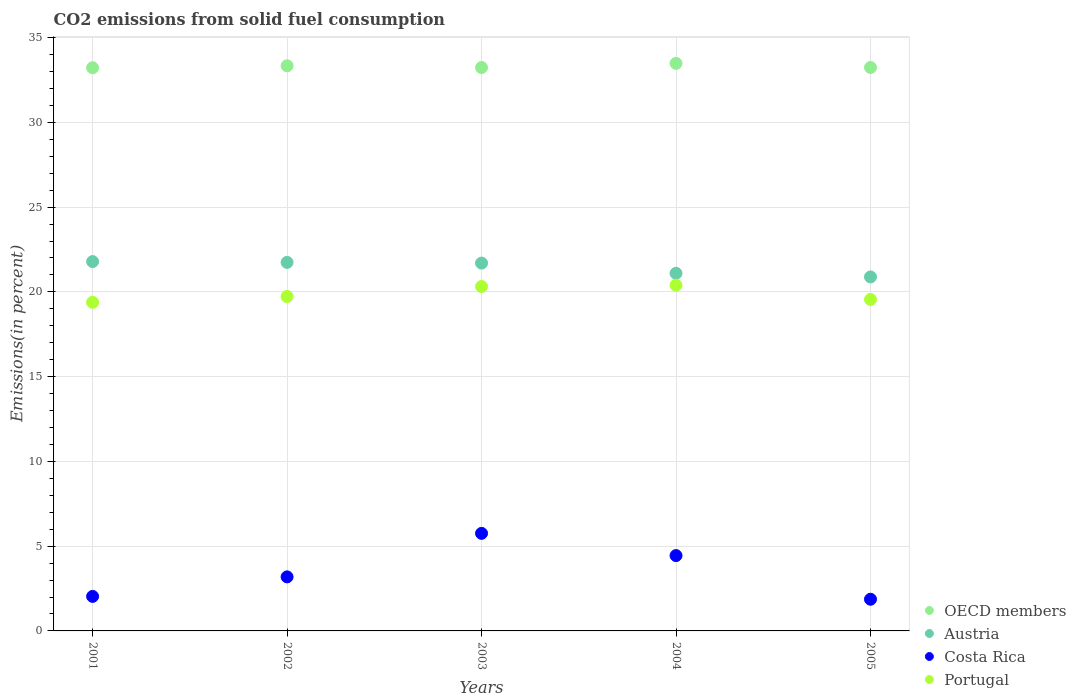How many different coloured dotlines are there?
Keep it short and to the point. 4. What is the total CO2 emitted in OECD members in 2002?
Keep it short and to the point. 33.34. Across all years, what is the maximum total CO2 emitted in Costa Rica?
Offer a terse response. 5.76. Across all years, what is the minimum total CO2 emitted in Portugal?
Your answer should be very brief. 19.38. In which year was the total CO2 emitted in Costa Rica maximum?
Ensure brevity in your answer.  2003. What is the total total CO2 emitted in Costa Rica in the graph?
Give a very brief answer. 17.29. What is the difference between the total CO2 emitted in Portugal in 2002 and that in 2004?
Offer a very short reply. -0.67. What is the difference between the total CO2 emitted in Portugal in 2002 and the total CO2 emitted in OECD members in 2001?
Your answer should be compact. -13.49. What is the average total CO2 emitted in Austria per year?
Your response must be concise. 21.44. In the year 2005, what is the difference between the total CO2 emitted in Portugal and total CO2 emitted in Austria?
Provide a succinct answer. -1.33. What is the ratio of the total CO2 emitted in OECD members in 2002 to that in 2005?
Provide a succinct answer. 1. Is the total CO2 emitted in OECD members in 2001 less than that in 2004?
Provide a succinct answer. Yes. Is the difference between the total CO2 emitted in Portugal in 2002 and 2004 greater than the difference between the total CO2 emitted in Austria in 2002 and 2004?
Keep it short and to the point. No. What is the difference between the highest and the second highest total CO2 emitted in Austria?
Your answer should be compact. 0.05. What is the difference between the highest and the lowest total CO2 emitted in Austria?
Offer a terse response. 0.91. In how many years, is the total CO2 emitted in Costa Rica greater than the average total CO2 emitted in Costa Rica taken over all years?
Give a very brief answer. 2. Is it the case that in every year, the sum of the total CO2 emitted in Austria and total CO2 emitted in Portugal  is greater than the total CO2 emitted in Costa Rica?
Keep it short and to the point. Yes. Is the total CO2 emitted in OECD members strictly greater than the total CO2 emitted in Austria over the years?
Ensure brevity in your answer.  Yes. How many years are there in the graph?
Make the answer very short. 5. Are the values on the major ticks of Y-axis written in scientific E-notation?
Offer a terse response. No. Does the graph contain any zero values?
Make the answer very short. No. Where does the legend appear in the graph?
Keep it short and to the point. Bottom right. How many legend labels are there?
Keep it short and to the point. 4. What is the title of the graph?
Provide a short and direct response. CO2 emissions from solid fuel consumption. What is the label or title of the X-axis?
Keep it short and to the point. Years. What is the label or title of the Y-axis?
Your answer should be compact. Emissions(in percent). What is the Emissions(in percent) in OECD members in 2001?
Keep it short and to the point. 33.22. What is the Emissions(in percent) in Austria in 2001?
Provide a succinct answer. 21.79. What is the Emissions(in percent) of Costa Rica in 2001?
Offer a very short reply. 2.04. What is the Emissions(in percent) of Portugal in 2001?
Your answer should be compact. 19.38. What is the Emissions(in percent) of OECD members in 2002?
Your answer should be compact. 33.34. What is the Emissions(in percent) of Austria in 2002?
Offer a very short reply. 21.74. What is the Emissions(in percent) in Costa Rica in 2002?
Give a very brief answer. 3.19. What is the Emissions(in percent) of Portugal in 2002?
Offer a terse response. 19.73. What is the Emissions(in percent) of OECD members in 2003?
Keep it short and to the point. 33.24. What is the Emissions(in percent) in Austria in 2003?
Your response must be concise. 21.7. What is the Emissions(in percent) of Costa Rica in 2003?
Your answer should be very brief. 5.76. What is the Emissions(in percent) in Portugal in 2003?
Your response must be concise. 20.32. What is the Emissions(in percent) of OECD members in 2004?
Offer a very short reply. 33.48. What is the Emissions(in percent) in Austria in 2004?
Make the answer very short. 21.1. What is the Emissions(in percent) of Costa Rica in 2004?
Provide a short and direct response. 4.44. What is the Emissions(in percent) in Portugal in 2004?
Your answer should be compact. 20.4. What is the Emissions(in percent) of OECD members in 2005?
Provide a succinct answer. 33.24. What is the Emissions(in percent) in Austria in 2005?
Keep it short and to the point. 20.88. What is the Emissions(in percent) in Costa Rica in 2005?
Ensure brevity in your answer.  1.87. What is the Emissions(in percent) in Portugal in 2005?
Your answer should be very brief. 19.56. Across all years, what is the maximum Emissions(in percent) in OECD members?
Keep it short and to the point. 33.48. Across all years, what is the maximum Emissions(in percent) of Austria?
Ensure brevity in your answer.  21.79. Across all years, what is the maximum Emissions(in percent) of Costa Rica?
Keep it short and to the point. 5.76. Across all years, what is the maximum Emissions(in percent) in Portugal?
Your answer should be very brief. 20.4. Across all years, what is the minimum Emissions(in percent) of OECD members?
Provide a short and direct response. 33.22. Across all years, what is the minimum Emissions(in percent) in Austria?
Give a very brief answer. 20.88. Across all years, what is the minimum Emissions(in percent) of Costa Rica?
Your answer should be compact. 1.87. Across all years, what is the minimum Emissions(in percent) in Portugal?
Offer a terse response. 19.38. What is the total Emissions(in percent) in OECD members in the graph?
Your response must be concise. 166.52. What is the total Emissions(in percent) of Austria in the graph?
Your answer should be compact. 107.21. What is the total Emissions(in percent) of Costa Rica in the graph?
Give a very brief answer. 17.29. What is the total Emissions(in percent) in Portugal in the graph?
Ensure brevity in your answer.  99.38. What is the difference between the Emissions(in percent) in OECD members in 2001 and that in 2002?
Give a very brief answer. -0.12. What is the difference between the Emissions(in percent) in Austria in 2001 and that in 2002?
Your response must be concise. 0.05. What is the difference between the Emissions(in percent) in Costa Rica in 2001 and that in 2002?
Ensure brevity in your answer.  -1.15. What is the difference between the Emissions(in percent) in Portugal in 2001 and that in 2002?
Provide a short and direct response. -0.34. What is the difference between the Emissions(in percent) in OECD members in 2001 and that in 2003?
Provide a succinct answer. -0.01. What is the difference between the Emissions(in percent) of Austria in 2001 and that in 2003?
Keep it short and to the point. 0.09. What is the difference between the Emissions(in percent) of Costa Rica in 2001 and that in 2003?
Ensure brevity in your answer.  -3.72. What is the difference between the Emissions(in percent) in Portugal in 2001 and that in 2003?
Make the answer very short. -0.93. What is the difference between the Emissions(in percent) of OECD members in 2001 and that in 2004?
Provide a succinct answer. -0.26. What is the difference between the Emissions(in percent) of Austria in 2001 and that in 2004?
Offer a very short reply. 0.69. What is the difference between the Emissions(in percent) of Costa Rica in 2001 and that in 2004?
Your response must be concise. -2.41. What is the difference between the Emissions(in percent) in Portugal in 2001 and that in 2004?
Your answer should be very brief. -1.01. What is the difference between the Emissions(in percent) in OECD members in 2001 and that in 2005?
Provide a succinct answer. -0.02. What is the difference between the Emissions(in percent) of Austria in 2001 and that in 2005?
Give a very brief answer. 0.91. What is the difference between the Emissions(in percent) in Costa Rica in 2001 and that in 2005?
Ensure brevity in your answer.  0.17. What is the difference between the Emissions(in percent) in Portugal in 2001 and that in 2005?
Give a very brief answer. -0.17. What is the difference between the Emissions(in percent) of OECD members in 2002 and that in 2003?
Your response must be concise. 0.1. What is the difference between the Emissions(in percent) in Austria in 2002 and that in 2003?
Provide a succinct answer. 0.04. What is the difference between the Emissions(in percent) of Costa Rica in 2002 and that in 2003?
Your response must be concise. -2.57. What is the difference between the Emissions(in percent) in Portugal in 2002 and that in 2003?
Provide a short and direct response. -0.59. What is the difference between the Emissions(in percent) in OECD members in 2002 and that in 2004?
Your answer should be compact. -0.14. What is the difference between the Emissions(in percent) in Austria in 2002 and that in 2004?
Your answer should be very brief. 0.64. What is the difference between the Emissions(in percent) of Costa Rica in 2002 and that in 2004?
Give a very brief answer. -1.26. What is the difference between the Emissions(in percent) in Portugal in 2002 and that in 2004?
Provide a succinct answer. -0.67. What is the difference between the Emissions(in percent) in OECD members in 2002 and that in 2005?
Offer a terse response. 0.1. What is the difference between the Emissions(in percent) of Austria in 2002 and that in 2005?
Your response must be concise. 0.86. What is the difference between the Emissions(in percent) of Costa Rica in 2002 and that in 2005?
Your answer should be very brief. 1.32. What is the difference between the Emissions(in percent) of Portugal in 2002 and that in 2005?
Your response must be concise. 0.17. What is the difference between the Emissions(in percent) of OECD members in 2003 and that in 2004?
Offer a terse response. -0.25. What is the difference between the Emissions(in percent) of Austria in 2003 and that in 2004?
Your response must be concise. 0.6. What is the difference between the Emissions(in percent) of Costa Rica in 2003 and that in 2004?
Offer a terse response. 1.31. What is the difference between the Emissions(in percent) of Portugal in 2003 and that in 2004?
Provide a succinct answer. -0.08. What is the difference between the Emissions(in percent) in OECD members in 2003 and that in 2005?
Your response must be concise. -0. What is the difference between the Emissions(in percent) in Austria in 2003 and that in 2005?
Your response must be concise. 0.82. What is the difference between the Emissions(in percent) in Costa Rica in 2003 and that in 2005?
Provide a short and direct response. 3.89. What is the difference between the Emissions(in percent) of Portugal in 2003 and that in 2005?
Give a very brief answer. 0.76. What is the difference between the Emissions(in percent) in OECD members in 2004 and that in 2005?
Offer a very short reply. 0.24. What is the difference between the Emissions(in percent) in Austria in 2004 and that in 2005?
Offer a terse response. 0.21. What is the difference between the Emissions(in percent) of Costa Rica in 2004 and that in 2005?
Ensure brevity in your answer.  2.58. What is the difference between the Emissions(in percent) of Portugal in 2004 and that in 2005?
Keep it short and to the point. 0.84. What is the difference between the Emissions(in percent) in OECD members in 2001 and the Emissions(in percent) in Austria in 2002?
Your answer should be compact. 11.48. What is the difference between the Emissions(in percent) in OECD members in 2001 and the Emissions(in percent) in Costa Rica in 2002?
Your answer should be very brief. 30.04. What is the difference between the Emissions(in percent) in OECD members in 2001 and the Emissions(in percent) in Portugal in 2002?
Offer a very short reply. 13.49. What is the difference between the Emissions(in percent) in Austria in 2001 and the Emissions(in percent) in Costa Rica in 2002?
Offer a very short reply. 18.6. What is the difference between the Emissions(in percent) of Austria in 2001 and the Emissions(in percent) of Portugal in 2002?
Ensure brevity in your answer.  2.06. What is the difference between the Emissions(in percent) of Costa Rica in 2001 and the Emissions(in percent) of Portugal in 2002?
Your answer should be compact. -17.69. What is the difference between the Emissions(in percent) of OECD members in 2001 and the Emissions(in percent) of Austria in 2003?
Your response must be concise. 11.52. What is the difference between the Emissions(in percent) of OECD members in 2001 and the Emissions(in percent) of Costa Rica in 2003?
Offer a terse response. 27.47. What is the difference between the Emissions(in percent) of OECD members in 2001 and the Emissions(in percent) of Portugal in 2003?
Keep it short and to the point. 12.91. What is the difference between the Emissions(in percent) of Austria in 2001 and the Emissions(in percent) of Costa Rica in 2003?
Offer a very short reply. 16.03. What is the difference between the Emissions(in percent) in Austria in 2001 and the Emissions(in percent) in Portugal in 2003?
Provide a succinct answer. 1.47. What is the difference between the Emissions(in percent) of Costa Rica in 2001 and the Emissions(in percent) of Portugal in 2003?
Your answer should be very brief. -18.28. What is the difference between the Emissions(in percent) in OECD members in 2001 and the Emissions(in percent) in Austria in 2004?
Your response must be concise. 12.13. What is the difference between the Emissions(in percent) of OECD members in 2001 and the Emissions(in percent) of Costa Rica in 2004?
Provide a succinct answer. 28.78. What is the difference between the Emissions(in percent) of OECD members in 2001 and the Emissions(in percent) of Portugal in 2004?
Your response must be concise. 12.83. What is the difference between the Emissions(in percent) in Austria in 2001 and the Emissions(in percent) in Costa Rica in 2004?
Your response must be concise. 17.34. What is the difference between the Emissions(in percent) of Austria in 2001 and the Emissions(in percent) of Portugal in 2004?
Give a very brief answer. 1.39. What is the difference between the Emissions(in percent) in Costa Rica in 2001 and the Emissions(in percent) in Portugal in 2004?
Your response must be concise. -18.36. What is the difference between the Emissions(in percent) of OECD members in 2001 and the Emissions(in percent) of Austria in 2005?
Provide a succinct answer. 12.34. What is the difference between the Emissions(in percent) of OECD members in 2001 and the Emissions(in percent) of Costa Rica in 2005?
Your answer should be compact. 31.35. What is the difference between the Emissions(in percent) in OECD members in 2001 and the Emissions(in percent) in Portugal in 2005?
Your answer should be very brief. 13.67. What is the difference between the Emissions(in percent) of Austria in 2001 and the Emissions(in percent) of Costa Rica in 2005?
Keep it short and to the point. 19.92. What is the difference between the Emissions(in percent) of Austria in 2001 and the Emissions(in percent) of Portugal in 2005?
Make the answer very short. 2.23. What is the difference between the Emissions(in percent) of Costa Rica in 2001 and the Emissions(in percent) of Portugal in 2005?
Give a very brief answer. -17.52. What is the difference between the Emissions(in percent) of OECD members in 2002 and the Emissions(in percent) of Austria in 2003?
Your response must be concise. 11.64. What is the difference between the Emissions(in percent) in OECD members in 2002 and the Emissions(in percent) in Costa Rica in 2003?
Give a very brief answer. 27.58. What is the difference between the Emissions(in percent) in OECD members in 2002 and the Emissions(in percent) in Portugal in 2003?
Ensure brevity in your answer.  13.02. What is the difference between the Emissions(in percent) of Austria in 2002 and the Emissions(in percent) of Costa Rica in 2003?
Your answer should be compact. 15.99. What is the difference between the Emissions(in percent) of Austria in 2002 and the Emissions(in percent) of Portugal in 2003?
Your response must be concise. 1.42. What is the difference between the Emissions(in percent) of Costa Rica in 2002 and the Emissions(in percent) of Portugal in 2003?
Provide a short and direct response. -17.13. What is the difference between the Emissions(in percent) of OECD members in 2002 and the Emissions(in percent) of Austria in 2004?
Keep it short and to the point. 12.24. What is the difference between the Emissions(in percent) of OECD members in 2002 and the Emissions(in percent) of Costa Rica in 2004?
Provide a succinct answer. 28.89. What is the difference between the Emissions(in percent) of OECD members in 2002 and the Emissions(in percent) of Portugal in 2004?
Make the answer very short. 12.94. What is the difference between the Emissions(in percent) in Austria in 2002 and the Emissions(in percent) in Costa Rica in 2004?
Provide a succinct answer. 17.3. What is the difference between the Emissions(in percent) in Austria in 2002 and the Emissions(in percent) in Portugal in 2004?
Make the answer very short. 1.34. What is the difference between the Emissions(in percent) in Costa Rica in 2002 and the Emissions(in percent) in Portugal in 2004?
Offer a terse response. -17.21. What is the difference between the Emissions(in percent) in OECD members in 2002 and the Emissions(in percent) in Austria in 2005?
Ensure brevity in your answer.  12.46. What is the difference between the Emissions(in percent) of OECD members in 2002 and the Emissions(in percent) of Costa Rica in 2005?
Your response must be concise. 31.47. What is the difference between the Emissions(in percent) in OECD members in 2002 and the Emissions(in percent) in Portugal in 2005?
Make the answer very short. 13.78. What is the difference between the Emissions(in percent) of Austria in 2002 and the Emissions(in percent) of Costa Rica in 2005?
Ensure brevity in your answer.  19.87. What is the difference between the Emissions(in percent) in Austria in 2002 and the Emissions(in percent) in Portugal in 2005?
Offer a very short reply. 2.18. What is the difference between the Emissions(in percent) in Costa Rica in 2002 and the Emissions(in percent) in Portugal in 2005?
Provide a short and direct response. -16.37. What is the difference between the Emissions(in percent) in OECD members in 2003 and the Emissions(in percent) in Austria in 2004?
Your answer should be compact. 12.14. What is the difference between the Emissions(in percent) in OECD members in 2003 and the Emissions(in percent) in Costa Rica in 2004?
Your response must be concise. 28.79. What is the difference between the Emissions(in percent) in OECD members in 2003 and the Emissions(in percent) in Portugal in 2004?
Offer a very short reply. 12.84. What is the difference between the Emissions(in percent) in Austria in 2003 and the Emissions(in percent) in Costa Rica in 2004?
Ensure brevity in your answer.  17.25. What is the difference between the Emissions(in percent) in Austria in 2003 and the Emissions(in percent) in Portugal in 2004?
Ensure brevity in your answer.  1.3. What is the difference between the Emissions(in percent) of Costa Rica in 2003 and the Emissions(in percent) of Portugal in 2004?
Ensure brevity in your answer.  -14.64. What is the difference between the Emissions(in percent) in OECD members in 2003 and the Emissions(in percent) in Austria in 2005?
Offer a terse response. 12.35. What is the difference between the Emissions(in percent) in OECD members in 2003 and the Emissions(in percent) in Costa Rica in 2005?
Keep it short and to the point. 31.37. What is the difference between the Emissions(in percent) of OECD members in 2003 and the Emissions(in percent) of Portugal in 2005?
Make the answer very short. 13.68. What is the difference between the Emissions(in percent) in Austria in 2003 and the Emissions(in percent) in Costa Rica in 2005?
Your answer should be compact. 19.83. What is the difference between the Emissions(in percent) of Austria in 2003 and the Emissions(in percent) of Portugal in 2005?
Your response must be concise. 2.14. What is the difference between the Emissions(in percent) in Costa Rica in 2003 and the Emissions(in percent) in Portugal in 2005?
Offer a terse response. -13.8. What is the difference between the Emissions(in percent) of OECD members in 2004 and the Emissions(in percent) of Austria in 2005?
Offer a very short reply. 12.6. What is the difference between the Emissions(in percent) in OECD members in 2004 and the Emissions(in percent) in Costa Rica in 2005?
Your answer should be very brief. 31.61. What is the difference between the Emissions(in percent) in OECD members in 2004 and the Emissions(in percent) in Portugal in 2005?
Give a very brief answer. 13.93. What is the difference between the Emissions(in percent) of Austria in 2004 and the Emissions(in percent) of Costa Rica in 2005?
Your response must be concise. 19.23. What is the difference between the Emissions(in percent) in Austria in 2004 and the Emissions(in percent) in Portugal in 2005?
Your answer should be very brief. 1.54. What is the difference between the Emissions(in percent) of Costa Rica in 2004 and the Emissions(in percent) of Portugal in 2005?
Provide a succinct answer. -15.11. What is the average Emissions(in percent) in OECD members per year?
Provide a short and direct response. 33.3. What is the average Emissions(in percent) in Austria per year?
Provide a succinct answer. 21.44. What is the average Emissions(in percent) in Costa Rica per year?
Offer a very short reply. 3.46. What is the average Emissions(in percent) in Portugal per year?
Make the answer very short. 19.88. In the year 2001, what is the difference between the Emissions(in percent) in OECD members and Emissions(in percent) in Austria?
Keep it short and to the point. 11.43. In the year 2001, what is the difference between the Emissions(in percent) of OECD members and Emissions(in percent) of Costa Rica?
Ensure brevity in your answer.  31.19. In the year 2001, what is the difference between the Emissions(in percent) of OECD members and Emissions(in percent) of Portugal?
Ensure brevity in your answer.  13.84. In the year 2001, what is the difference between the Emissions(in percent) of Austria and Emissions(in percent) of Costa Rica?
Provide a succinct answer. 19.75. In the year 2001, what is the difference between the Emissions(in percent) of Austria and Emissions(in percent) of Portugal?
Provide a short and direct response. 2.41. In the year 2001, what is the difference between the Emissions(in percent) of Costa Rica and Emissions(in percent) of Portugal?
Ensure brevity in your answer.  -17.35. In the year 2002, what is the difference between the Emissions(in percent) in OECD members and Emissions(in percent) in Austria?
Provide a short and direct response. 11.6. In the year 2002, what is the difference between the Emissions(in percent) of OECD members and Emissions(in percent) of Costa Rica?
Offer a terse response. 30.15. In the year 2002, what is the difference between the Emissions(in percent) in OECD members and Emissions(in percent) in Portugal?
Keep it short and to the point. 13.61. In the year 2002, what is the difference between the Emissions(in percent) of Austria and Emissions(in percent) of Costa Rica?
Make the answer very short. 18.55. In the year 2002, what is the difference between the Emissions(in percent) of Austria and Emissions(in percent) of Portugal?
Offer a terse response. 2.01. In the year 2002, what is the difference between the Emissions(in percent) of Costa Rica and Emissions(in percent) of Portugal?
Ensure brevity in your answer.  -16.54. In the year 2003, what is the difference between the Emissions(in percent) in OECD members and Emissions(in percent) in Austria?
Provide a succinct answer. 11.54. In the year 2003, what is the difference between the Emissions(in percent) in OECD members and Emissions(in percent) in Costa Rica?
Your response must be concise. 27.48. In the year 2003, what is the difference between the Emissions(in percent) in OECD members and Emissions(in percent) in Portugal?
Ensure brevity in your answer.  12.92. In the year 2003, what is the difference between the Emissions(in percent) of Austria and Emissions(in percent) of Costa Rica?
Provide a short and direct response. 15.94. In the year 2003, what is the difference between the Emissions(in percent) in Austria and Emissions(in percent) in Portugal?
Keep it short and to the point. 1.38. In the year 2003, what is the difference between the Emissions(in percent) of Costa Rica and Emissions(in percent) of Portugal?
Ensure brevity in your answer.  -14.56. In the year 2004, what is the difference between the Emissions(in percent) of OECD members and Emissions(in percent) of Austria?
Ensure brevity in your answer.  12.38. In the year 2004, what is the difference between the Emissions(in percent) in OECD members and Emissions(in percent) in Costa Rica?
Your answer should be compact. 29.04. In the year 2004, what is the difference between the Emissions(in percent) of OECD members and Emissions(in percent) of Portugal?
Provide a succinct answer. 13.08. In the year 2004, what is the difference between the Emissions(in percent) in Austria and Emissions(in percent) in Costa Rica?
Ensure brevity in your answer.  16.65. In the year 2004, what is the difference between the Emissions(in percent) of Austria and Emissions(in percent) of Portugal?
Provide a short and direct response. 0.7. In the year 2004, what is the difference between the Emissions(in percent) in Costa Rica and Emissions(in percent) in Portugal?
Offer a very short reply. -15.95. In the year 2005, what is the difference between the Emissions(in percent) of OECD members and Emissions(in percent) of Austria?
Offer a very short reply. 12.36. In the year 2005, what is the difference between the Emissions(in percent) of OECD members and Emissions(in percent) of Costa Rica?
Provide a short and direct response. 31.37. In the year 2005, what is the difference between the Emissions(in percent) in OECD members and Emissions(in percent) in Portugal?
Keep it short and to the point. 13.68. In the year 2005, what is the difference between the Emissions(in percent) of Austria and Emissions(in percent) of Costa Rica?
Offer a terse response. 19.01. In the year 2005, what is the difference between the Emissions(in percent) in Austria and Emissions(in percent) in Portugal?
Offer a very short reply. 1.33. In the year 2005, what is the difference between the Emissions(in percent) in Costa Rica and Emissions(in percent) in Portugal?
Provide a short and direct response. -17.69. What is the ratio of the Emissions(in percent) of Austria in 2001 to that in 2002?
Provide a short and direct response. 1. What is the ratio of the Emissions(in percent) of Costa Rica in 2001 to that in 2002?
Provide a succinct answer. 0.64. What is the ratio of the Emissions(in percent) of Portugal in 2001 to that in 2002?
Ensure brevity in your answer.  0.98. What is the ratio of the Emissions(in percent) of Costa Rica in 2001 to that in 2003?
Your answer should be very brief. 0.35. What is the ratio of the Emissions(in percent) of Portugal in 2001 to that in 2003?
Keep it short and to the point. 0.95. What is the ratio of the Emissions(in percent) of Austria in 2001 to that in 2004?
Provide a short and direct response. 1.03. What is the ratio of the Emissions(in percent) in Costa Rica in 2001 to that in 2004?
Your answer should be compact. 0.46. What is the ratio of the Emissions(in percent) of Portugal in 2001 to that in 2004?
Offer a very short reply. 0.95. What is the ratio of the Emissions(in percent) of OECD members in 2001 to that in 2005?
Give a very brief answer. 1. What is the ratio of the Emissions(in percent) in Austria in 2001 to that in 2005?
Offer a terse response. 1.04. What is the ratio of the Emissions(in percent) in Costa Rica in 2001 to that in 2005?
Provide a succinct answer. 1.09. What is the ratio of the Emissions(in percent) in Austria in 2002 to that in 2003?
Keep it short and to the point. 1. What is the ratio of the Emissions(in percent) in Costa Rica in 2002 to that in 2003?
Provide a succinct answer. 0.55. What is the ratio of the Emissions(in percent) in OECD members in 2002 to that in 2004?
Offer a very short reply. 1. What is the ratio of the Emissions(in percent) in Austria in 2002 to that in 2004?
Your answer should be compact. 1.03. What is the ratio of the Emissions(in percent) in Costa Rica in 2002 to that in 2004?
Make the answer very short. 0.72. What is the ratio of the Emissions(in percent) of Portugal in 2002 to that in 2004?
Your answer should be compact. 0.97. What is the ratio of the Emissions(in percent) in Austria in 2002 to that in 2005?
Your response must be concise. 1.04. What is the ratio of the Emissions(in percent) of Costa Rica in 2002 to that in 2005?
Provide a short and direct response. 1.71. What is the ratio of the Emissions(in percent) in Portugal in 2002 to that in 2005?
Your answer should be compact. 1.01. What is the ratio of the Emissions(in percent) in OECD members in 2003 to that in 2004?
Keep it short and to the point. 0.99. What is the ratio of the Emissions(in percent) of Austria in 2003 to that in 2004?
Your response must be concise. 1.03. What is the ratio of the Emissions(in percent) of Costa Rica in 2003 to that in 2004?
Keep it short and to the point. 1.29. What is the ratio of the Emissions(in percent) in Austria in 2003 to that in 2005?
Offer a very short reply. 1.04. What is the ratio of the Emissions(in percent) in Costa Rica in 2003 to that in 2005?
Ensure brevity in your answer.  3.08. What is the ratio of the Emissions(in percent) in Portugal in 2003 to that in 2005?
Make the answer very short. 1.04. What is the ratio of the Emissions(in percent) of Austria in 2004 to that in 2005?
Provide a succinct answer. 1.01. What is the ratio of the Emissions(in percent) in Costa Rica in 2004 to that in 2005?
Your answer should be very brief. 2.38. What is the ratio of the Emissions(in percent) of Portugal in 2004 to that in 2005?
Make the answer very short. 1.04. What is the difference between the highest and the second highest Emissions(in percent) in OECD members?
Your answer should be very brief. 0.14. What is the difference between the highest and the second highest Emissions(in percent) in Austria?
Your answer should be compact. 0.05. What is the difference between the highest and the second highest Emissions(in percent) of Costa Rica?
Offer a very short reply. 1.31. What is the difference between the highest and the second highest Emissions(in percent) in Portugal?
Your response must be concise. 0.08. What is the difference between the highest and the lowest Emissions(in percent) of OECD members?
Give a very brief answer. 0.26. What is the difference between the highest and the lowest Emissions(in percent) in Austria?
Give a very brief answer. 0.91. What is the difference between the highest and the lowest Emissions(in percent) of Costa Rica?
Your answer should be very brief. 3.89. What is the difference between the highest and the lowest Emissions(in percent) of Portugal?
Keep it short and to the point. 1.01. 